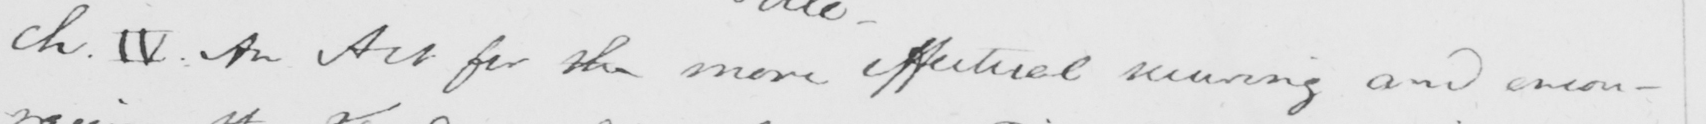Please transcribe the handwritten text in this image. ch . IV . An Act for the more effectual securing and encou- 